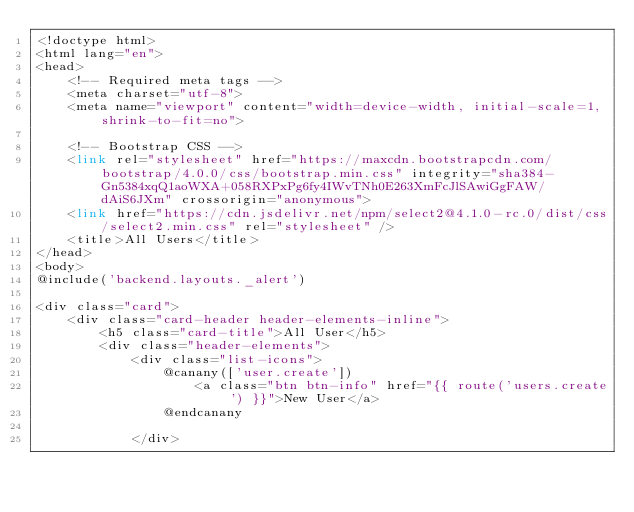Convert code to text. <code><loc_0><loc_0><loc_500><loc_500><_PHP_><!doctype html>
<html lang="en">
<head>
    <!-- Required meta tags -->
    <meta charset="utf-8">
    <meta name="viewport" content="width=device-width, initial-scale=1, shrink-to-fit=no">

    <!-- Bootstrap CSS -->
    <link rel="stylesheet" href="https://maxcdn.bootstrapcdn.com/bootstrap/4.0.0/css/bootstrap.min.css" integrity="sha384-Gn5384xqQ1aoWXA+058RXPxPg6fy4IWvTNh0E263XmFcJlSAwiGgFAW/dAiS6JXm" crossorigin="anonymous">
    <link href="https://cdn.jsdelivr.net/npm/select2@4.1.0-rc.0/dist/css/select2.min.css" rel="stylesheet" />
    <title>All Users</title>
</head>
<body>
@include('backend.layouts._alert')

<div class="card">
    <div class="card-header header-elements-inline">
        <h5 class="card-title">All User</h5>
        <div class="header-elements">
            <div class="list-icons">
                @canany(['user.create'])
                    <a class="btn btn-info" href="{{ route('users.create') }}">New User</a>
                @endcanany

            </div></code> 